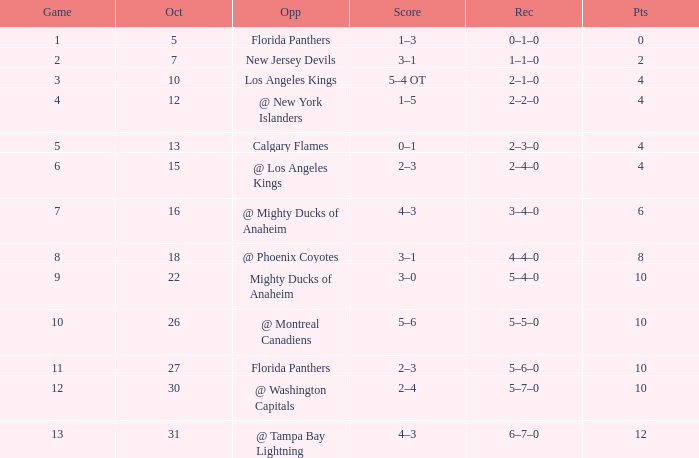What team has a score of 2 3–1. 